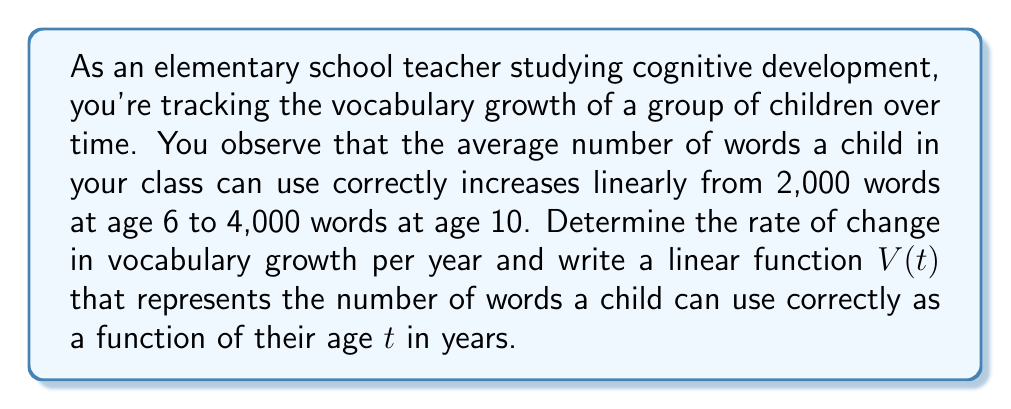Help me with this question. To solve this problem, we need to use the concept of linear functions and rate of change. Let's break it down step-by-step:

1. Identify the given information:
   - At age 6, children can use 2,000 words correctly
   - At age 10, children can use 4,000 words correctly

2. Calculate the rate of change (slope):
   Rate of change = $\frac{\text{Change in words}}{\text{Change in age}}$
   
   $$ \text{Rate of change} = \frac{4000 - 2000}{10 - 6} = \frac{2000}{4} = 500 \text{ words per year} $$

3. Now that we have the rate of change, we can form a linear function in the slope-intercept form:
   $V(t) = mt + b$, where $m$ is the slope (rate of change) and $b$ is the y-intercept.

4. We know the slope $m = 500$. To find $b$, we can use either of the given points. Let's use (6, 2000):
   
   $2000 = 500(6) + b$
   $2000 = 3000 + b$
   $b = -1000$

5. Therefore, our linear function is:
   $V(t) = 500t - 1000$

This function represents the number of words $V$ a child can use correctly as a function of their age $t$ in years.
Answer: The rate of change in vocabulary growth is 500 words per year.
The linear function representing vocabulary growth is $V(t) = 500t - 1000$, where $V$ is the number of words and $t$ is the age in years. 